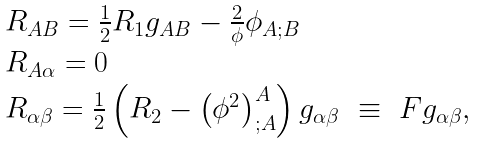<formula> <loc_0><loc_0><loc_500><loc_500>\begin{array} { l } R _ { A B } = \frac { 1 } { 2 } R _ { 1 } g _ { A B } - \frac { 2 } { \phi } \phi _ { A ; B } \\ R _ { A \alpha } = 0 \\ R _ { \alpha \beta } = \frac { 1 } { 2 } \left ( R _ { 2 } - \left ( \phi ^ { 2 } \right ) _ { ; A } ^ { A } \right ) g _ { \alpha \beta } \ \equiv \ F g _ { \alpha \beta } , \end{array}</formula> 